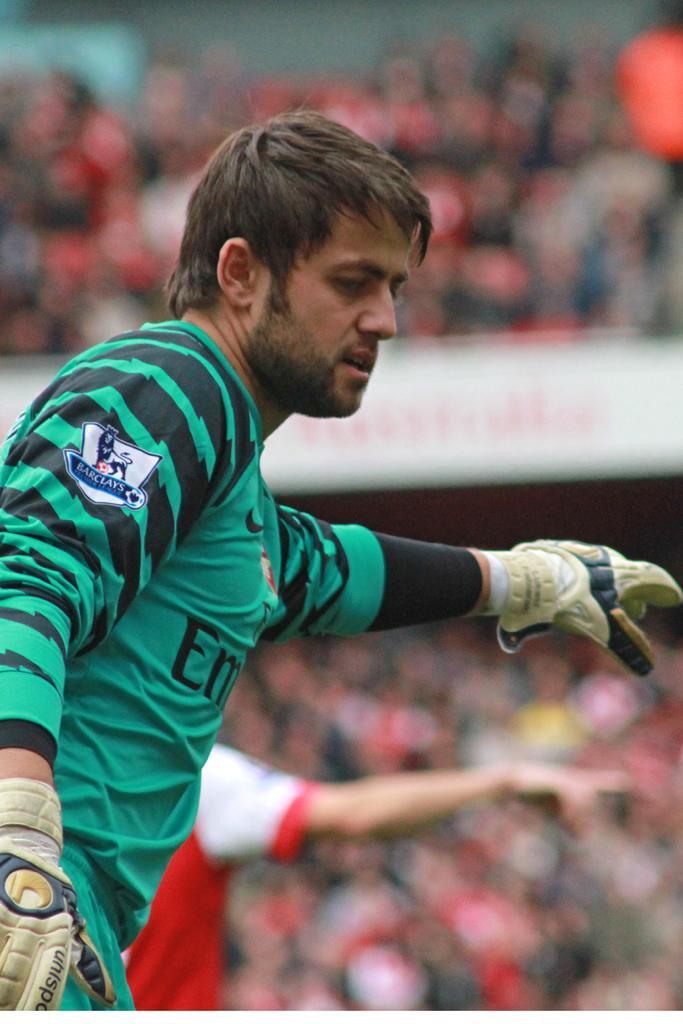How would you summarize this image in a sentence or two? In this picture I can see a man on the left side. He is wearing a t-shirt, behind him there is another person, in the background there is the blur. 